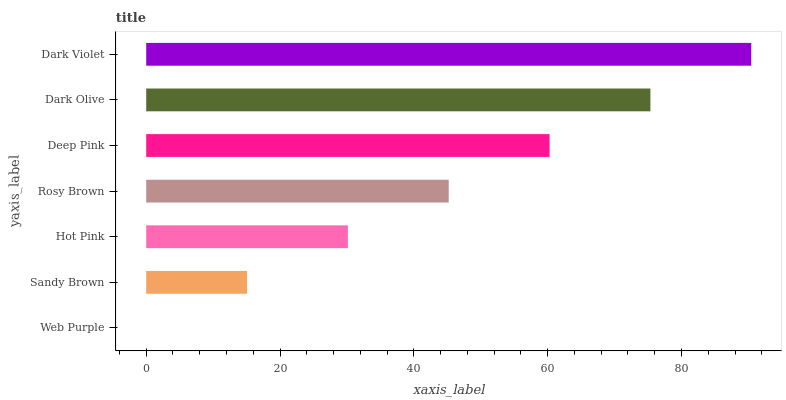Is Web Purple the minimum?
Answer yes or no. Yes. Is Dark Violet the maximum?
Answer yes or no. Yes. Is Sandy Brown the minimum?
Answer yes or no. No. Is Sandy Brown the maximum?
Answer yes or no. No. Is Sandy Brown greater than Web Purple?
Answer yes or no. Yes. Is Web Purple less than Sandy Brown?
Answer yes or no. Yes. Is Web Purple greater than Sandy Brown?
Answer yes or no. No. Is Sandy Brown less than Web Purple?
Answer yes or no. No. Is Rosy Brown the high median?
Answer yes or no. Yes. Is Rosy Brown the low median?
Answer yes or no. Yes. Is Web Purple the high median?
Answer yes or no. No. Is Web Purple the low median?
Answer yes or no. No. 